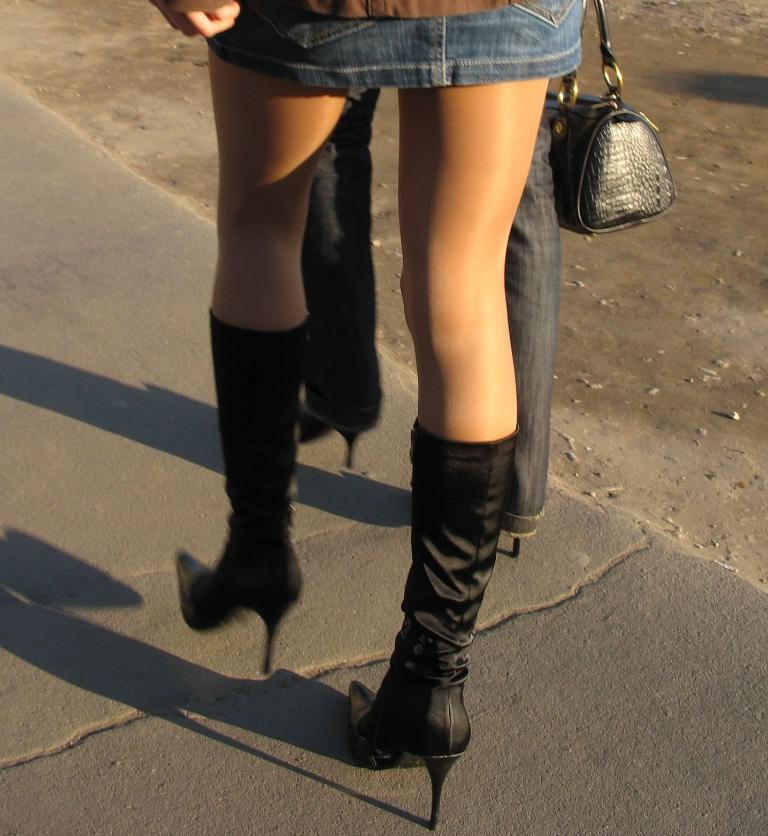What body parts of a person can be seen in the image? There are person's legs visible in the image. What type of footwear is the person wearing? The person is wearing heels. What accessory is present in the image? There is a bag in the image. Where is the person located in the image? The person is on a path. What type of egg is being used to tie a knot in the image? There is no egg or knot present in the image. How is the rice being prepared in the image? There is no rice present in the image. 